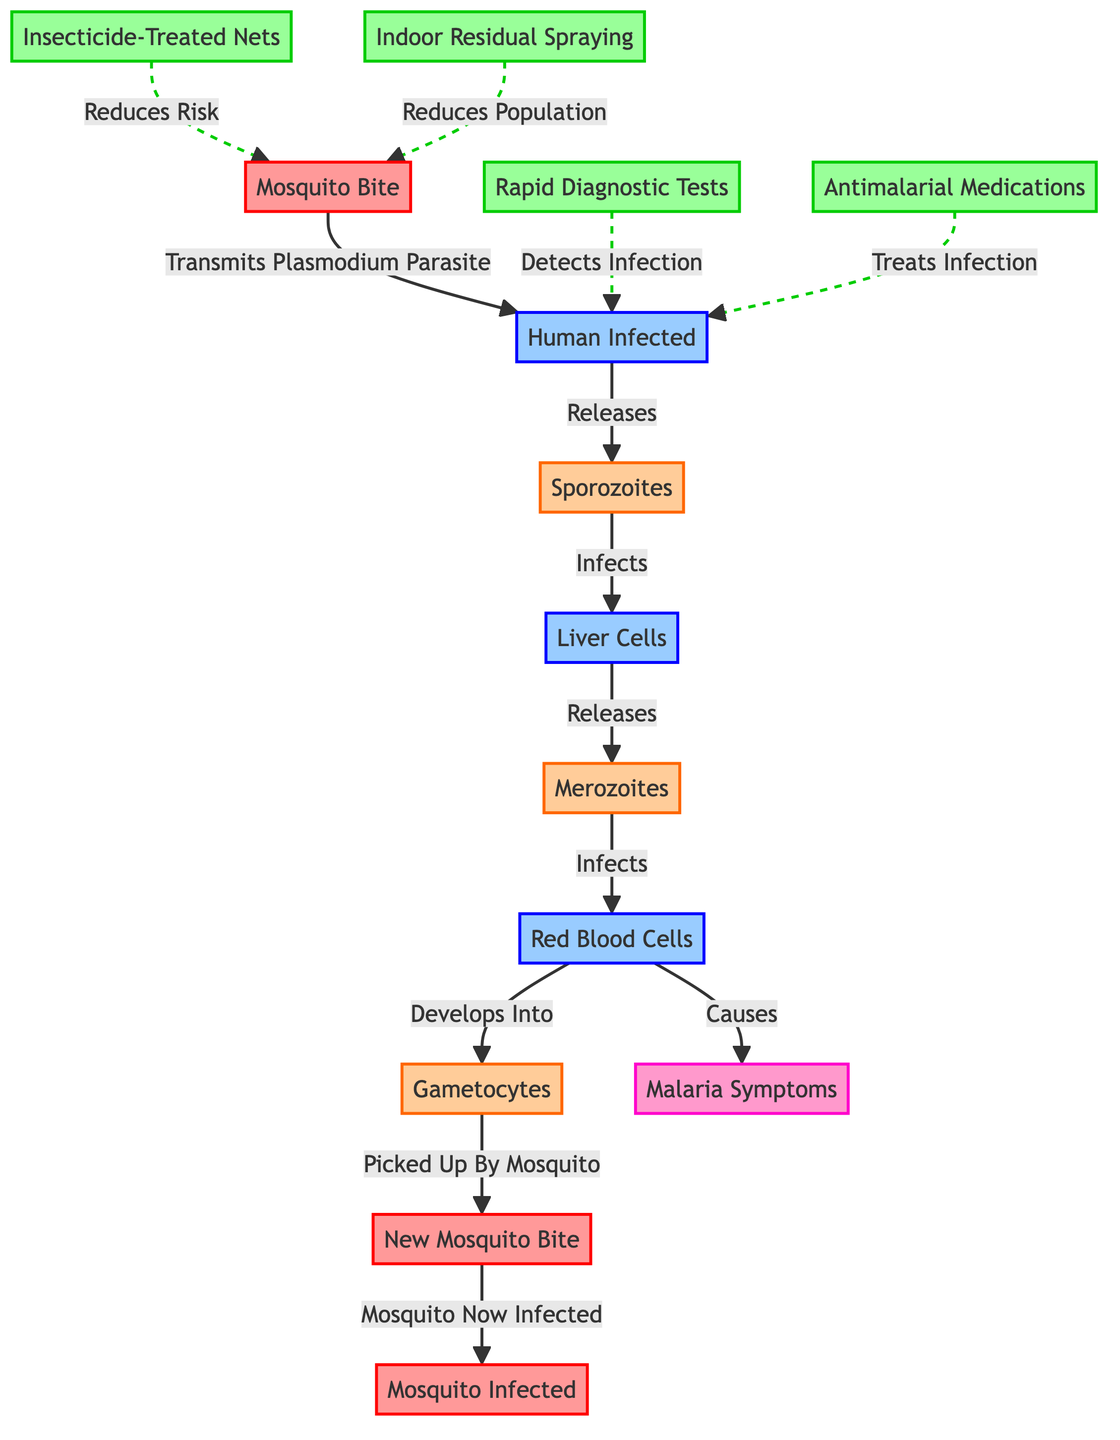What is transmitted by a mosquito bite? The diagram indicates that a mosquito bite transmits the Plasmodium parasite to a human. This is represented by the flow from the node "Mosquito Bite" to the node "Human Infected."
Answer: Plasmodium parasite How many prevention strategies are shown in the diagram? There are four prevention strategies represented in the diagram: Insecticide-Treated Nets, Indoor Residual Spraying, Rapid Diagnostic Tests, and Antimalarial Medications. Counting these nodes gives a total of four.
Answer: 4 Which phase does the Plasmodium parasite infect liver cells? The diagram shows that the Plasmodium parasite, once released from the human, infects liver cells at the node labeled "Liver Cells." This is exhibited in the flow from the node "Sporozoites" to "Liver Cells."
Answer: Liver Cells What develops from red blood cells according to the diagram? The diagram illustrates that merozoites develop from the infected red blood cells, identified at the node "Red Blood Cells," leading to the node "Gametocytes." This is clearly shown in the flow indicated in the diagram.
Answer: Gametocytes What is the effect of Insecticide-Treated Nets mentioned in the diagram? The diagram uses a dashed line to indicate that Insecticide-Treated Nets reduce the risk of a mosquito bite, connecting the prevention strategy to the mosquito bite node. This implies a protective measure against transmission.
Answer: Reduces Risk 